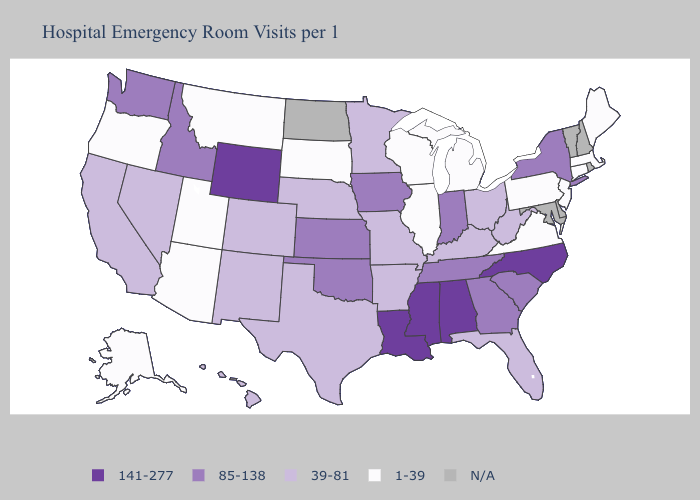Name the states that have a value in the range N/A?
Answer briefly. Delaware, Maryland, New Hampshire, North Dakota, Rhode Island, Vermont. Does Arkansas have the highest value in the South?
Be succinct. No. Name the states that have a value in the range N/A?
Short answer required. Delaware, Maryland, New Hampshire, North Dakota, Rhode Island, Vermont. What is the value of Alaska?
Be succinct. 1-39. Among the states that border North Dakota , which have the highest value?
Give a very brief answer. Minnesota. Does New Jersey have the highest value in the USA?
Quick response, please. No. Name the states that have a value in the range 85-138?
Be succinct. Georgia, Idaho, Indiana, Iowa, Kansas, New York, Oklahoma, South Carolina, Tennessee, Washington. Name the states that have a value in the range 39-81?
Short answer required. Arkansas, California, Colorado, Florida, Hawaii, Kentucky, Minnesota, Missouri, Nebraska, Nevada, New Mexico, Ohio, Texas, West Virginia. What is the highest value in the USA?
Be succinct. 141-277. Name the states that have a value in the range 1-39?
Be succinct. Alaska, Arizona, Connecticut, Illinois, Maine, Massachusetts, Michigan, Montana, New Jersey, Oregon, Pennsylvania, South Dakota, Utah, Virginia, Wisconsin. What is the value of Tennessee?
Write a very short answer. 85-138. Which states hav the highest value in the Northeast?
Write a very short answer. New York. Name the states that have a value in the range 85-138?
Quick response, please. Georgia, Idaho, Indiana, Iowa, Kansas, New York, Oklahoma, South Carolina, Tennessee, Washington. Name the states that have a value in the range 39-81?
Keep it brief. Arkansas, California, Colorado, Florida, Hawaii, Kentucky, Minnesota, Missouri, Nebraska, Nevada, New Mexico, Ohio, Texas, West Virginia. 